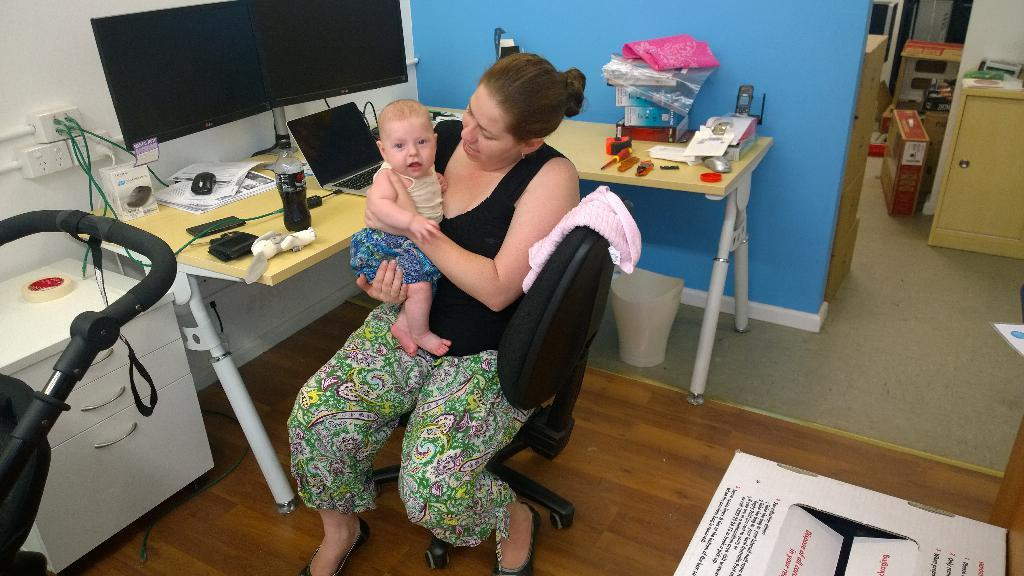What is the woman doing in the image? The woman is carrying a child in the image. Where is the woman sitting? The woman is sitting on a chair in the image. What electronic devices are present in the image? There is a monitor, a mouse, and a laptop in the image. What is the woman holding in her hand? The woman is holding a bottle in the image. What else can be seen on the table? There are some unspecified things on the table in the image. How many fish are swimming in the territory of the owl in the image? There are no fish or owls present in the image. 